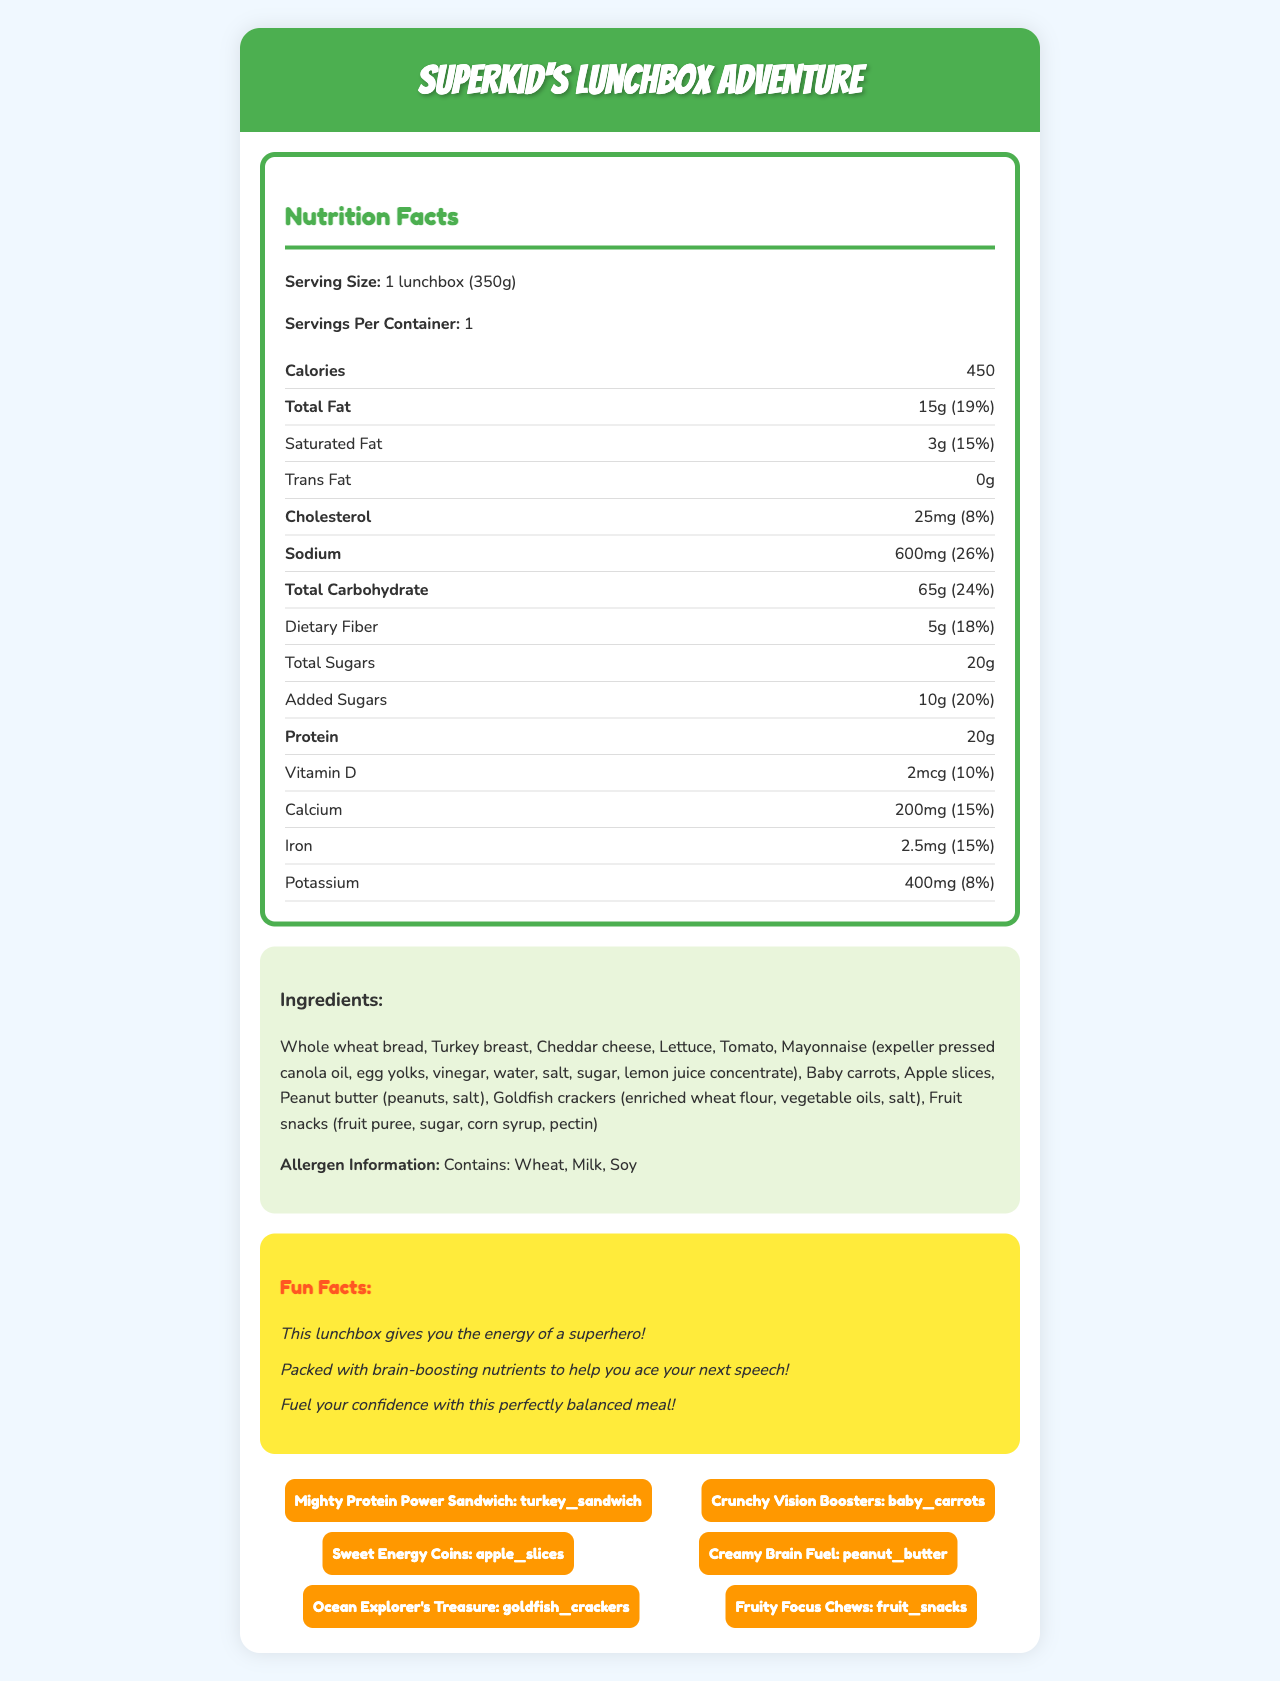what is the serving size of the SuperKid's Lunchbox Adventure? The serving size is listed at the top of the Nutrition Facts section as "1 lunchbox (350g)."
Answer: 1 lunchbox (350g) how many calories are in one serving of the lunchbox? The number of calories is specified in the Nutrition Facts section as "450."
Answer: 450 how much protein does the lunchbox contain? The amount of protein is listed in the Nutrition Facts section as "20g."
Answer: 20g what percentage of the daily value of calcium does the lunchbox provide? Under the Nutrition Facts, calcium is shown to provide "200mg (15%)."
Answer: 15% how many grams of total sugars are in the lunchbox? The Nutrition Facts section lists total sugars as "20g."
Answer: 20g which ingredients are in the peanut butter? A. Peanuts, salt B. Peanuts, sugar C. Peanuts, salt, sugar D. Peanuts, salt, corn syrup In the Ingredients list, peanut butter is described as containing "peanuts, salt."
Answer: A. Peanuts, salt what are the fun facts mentioned about the lunchbox meal? A. Gives you energy B. Boosts brainpower C. Helps with confidence D. All of the above The Fun Facts section lists three points: "This lunchbox gives you the energy of a superhero!", "Packed with brain-boosting nutrients to help you ace your next speech!", and "Fuel your confidence with this perfectly balanced meal!"
Answer: D. All of the above does the lunchbox contain any trans fat? The Nutrition Facts section shows trans fat as "0g."
Answer: No summarize the main idea of the document. The document includes several sections detailing nutrition, ingredients, allergen information, fun facts, and creative names designed to make the meal interesting and appealing to kids.
Answer: The document provides detailed nutritional information, ingredients, fun facts, and kid-friendly names for the "SuperKid's Lunchbox Adventure" meal. It emphasizes the meal’s balance and its appeal to children, highlighting the energy and nutrients it provides. what is the amount of sodium in the lunchbox? and why is this important? The Nutrition Facts state that the sodium content is "600mg (26% daily value)." This is important as high sodium levels can contribute to health issues such as high blood pressure.
Answer: 600mg (26% daily value) how many servings are in one container of the lunchbox? The Nutrition Facts state there is "1 serving per container."
Answer: 1 what does the "Mighty Protein Power Sandwich" consist of? In the Ingredients list, these components match the "Mighty Protein Power Sandwich."
Answer: Turkey breast, cheddar cheese, lettuce, tomato, whole wheat bread, mayonnaise is there any information about potential allergens in the lunchbox? The Allergen Information section states that the meal contains wheat, milk, and soy.
Answer: Yes what is the iron content and its daily value percentage in the lunchbox? The Nutrition Facts section lists iron content as "2.5mg (15%)."
Answer: 2.5mg (15%) how much dietary fiber is in the lunchbox? The Nutrition Facts indicate dietary fiber as "5g (18%)."
Answer: 5g (18%) which of the following is not listed among the ingredients? A. Whole wheat bread B. Turkey breast C. Almonds D. Goldfish crackers The Ingredients list does not include almonds.
Answer: C. Almonds what is the "Ocean Explorer's Treasure"? The Kid-Friendly Names section labels Goldfish Crackers as "Ocean Explorer's Treasure."
Answer: Goldfish Crackers what benefit does the lunchbox provide according to one of the fun facts? The Fun Facts section mentions, "Packed with brain-boosting nutrients to help you ace your next speech!"
Answer: Brain-boosting nutrients what percentage of the daily value for Vitamin D does this meal provide? In the Nutrition Facts section, Vitamin D is shown to provide "2mcg (10%)."
Answer: 10% how much cholesterol is in the meal? The Nutrition Facts section lists cholesterol as "25mg (8%)."
Answer: 25mg (8%) what are the "Crunchy Vision Boosters"? The Kid-Friendly Names section refers to baby carrots as "Crunchy Vision Boosters."
Answer: Baby Carrots what flavor are the fruit snacks? The document does not specify the flavor of the fruit snacks.
Answer: Cannot be determined what do the fun facts suggest about eating this lunchbox? The Fun Facts section mentions these three benefits related to energy, brainpower, and confidence.
Answer: Provides energy, boosts brainpower, fuels confidence 